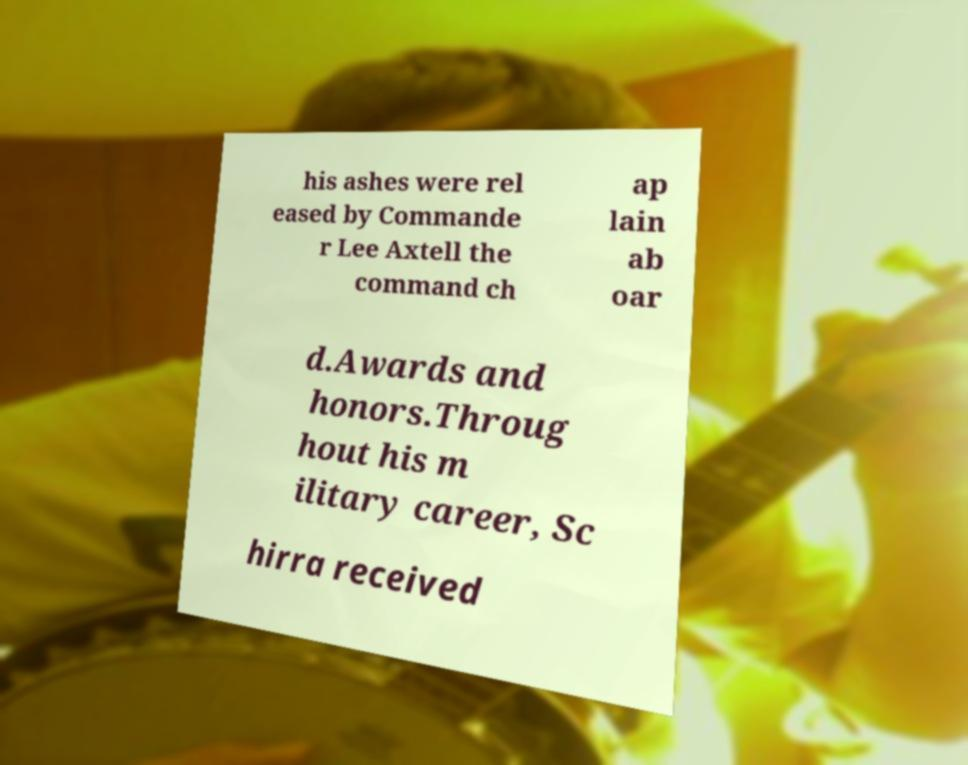Can you accurately transcribe the text from the provided image for me? his ashes were rel eased by Commande r Lee Axtell the command ch ap lain ab oar d.Awards and honors.Throug hout his m ilitary career, Sc hirra received 